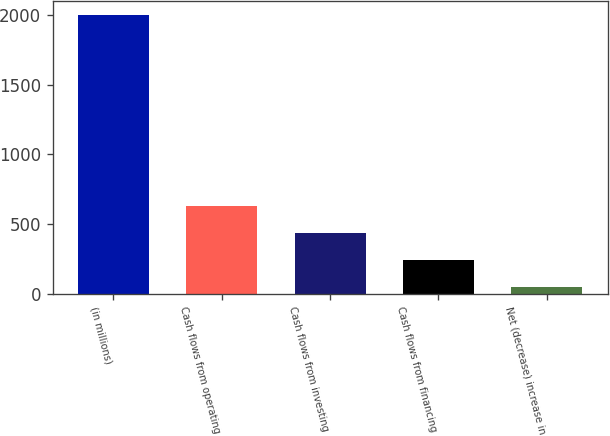Convert chart to OTSL. <chart><loc_0><loc_0><loc_500><loc_500><bar_chart><fcel>(in millions)<fcel>Cash flows from operating<fcel>Cash flows from investing<fcel>Cash flows from financing<fcel>Net (decrease) increase in<nl><fcel>2004<fcel>632.56<fcel>436.64<fcel>240.72<fcel>44.8<nl></chart> 